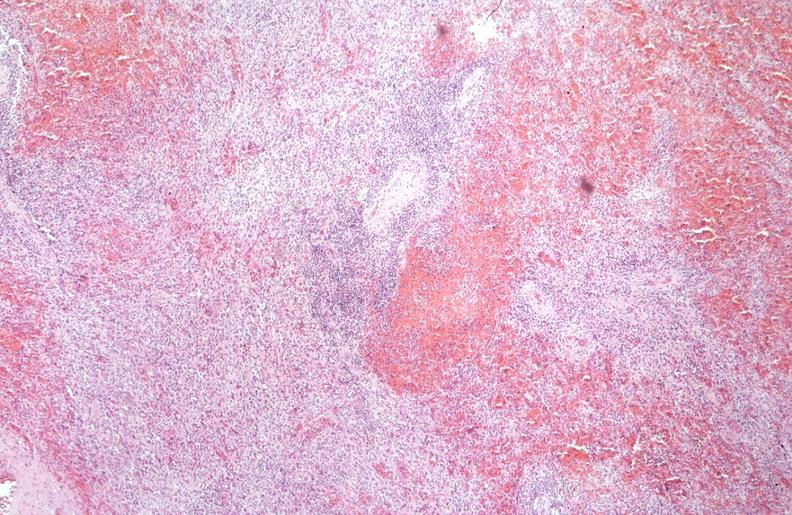s infant body present?
Answer the question using a single word or phrase. No 